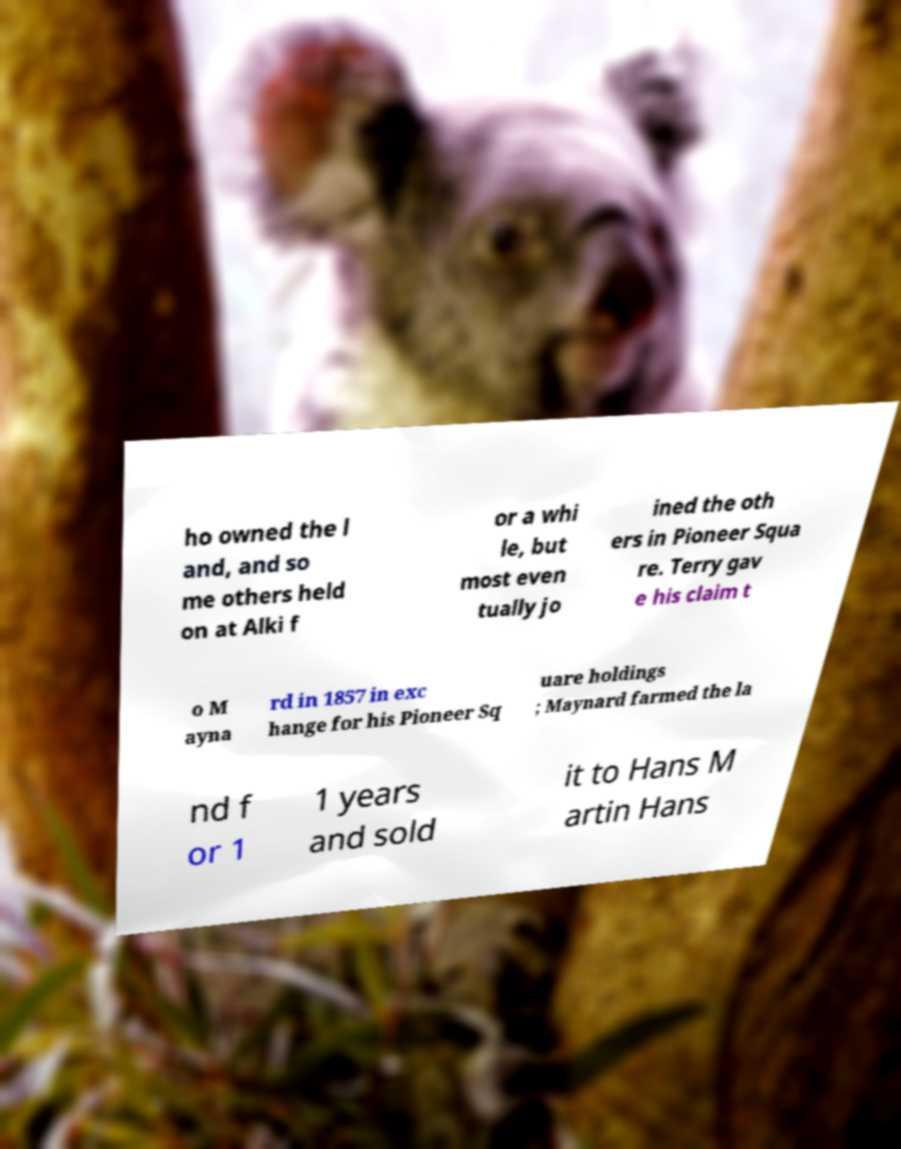What messages or text are displayed in this image? I need them in a readable, typed format. ho owned the l and, and so me others held on at Alki f or a whi le, but most even tually jo ined the oth ers in Pioneer Squa re. Terry gav e his claim t o M ayna rd in 1857 in exc hange for his Pioneer Sq uare holdings ; Maynard farmed the la nd f or 1 1 years and sold it to Hans M artin Hans 